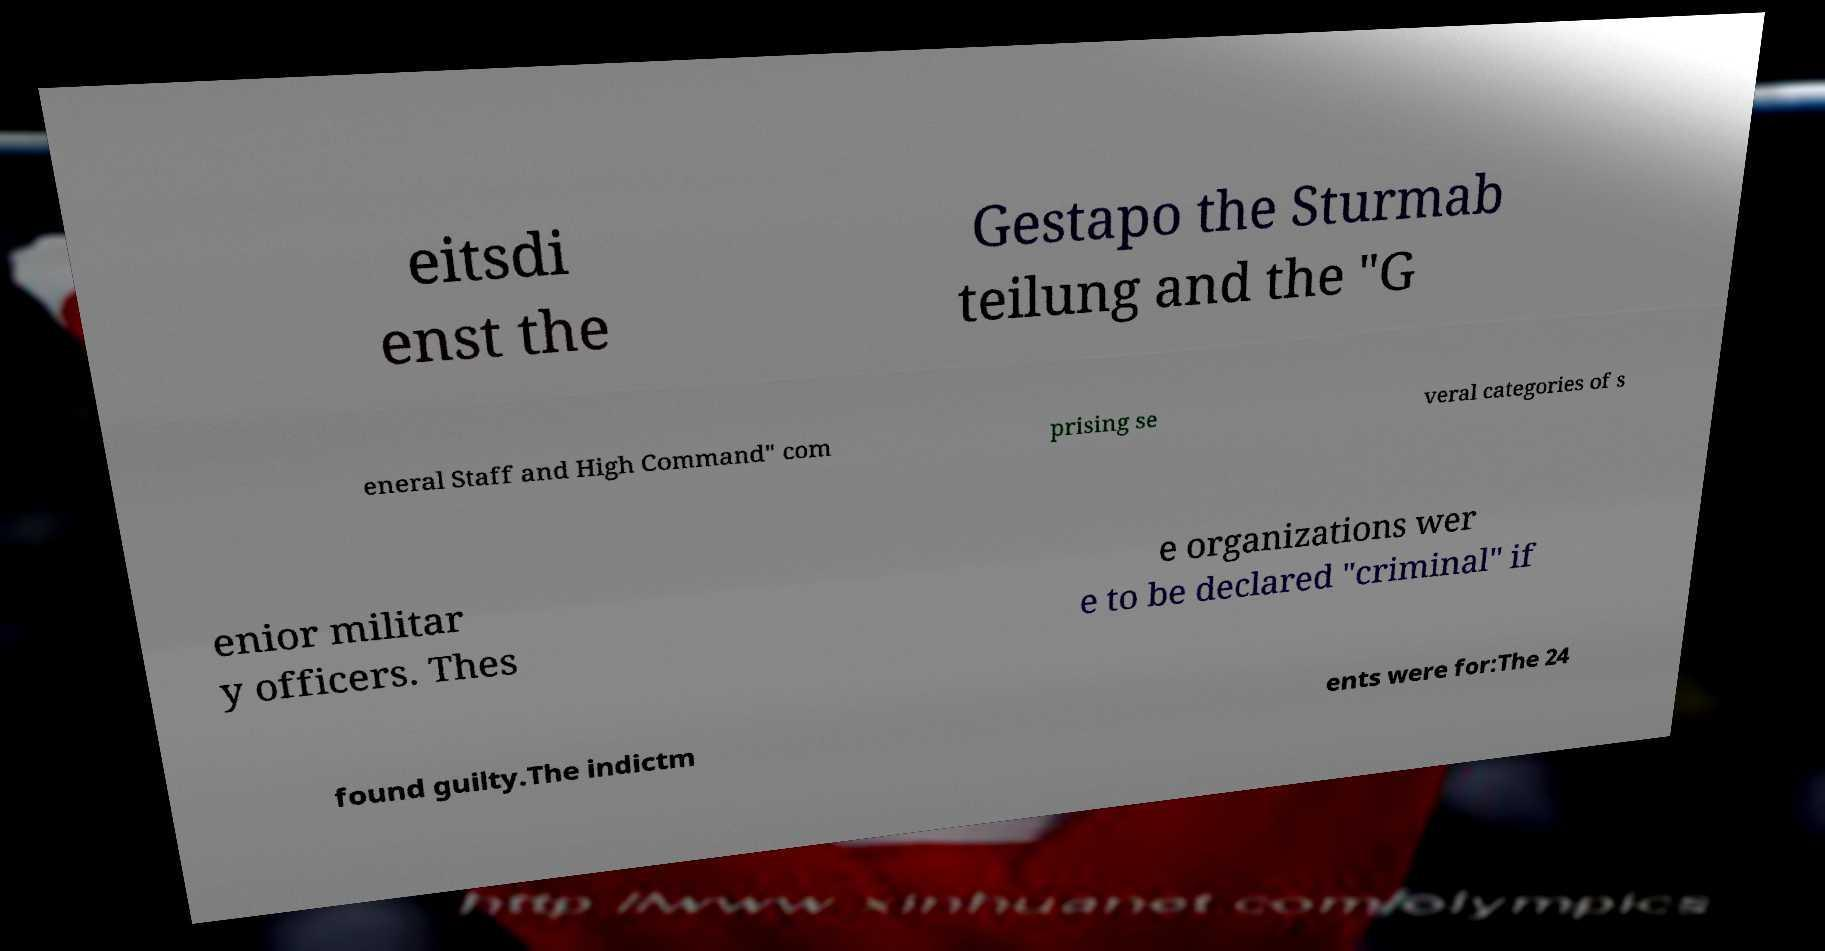Could you assist in decoding the text presented in this image and type it out clearly? eitsdi enst the Gestapo the Sturmab teilung and the "G eneral Staff and High Command" com prising se veral categories of s enior militar y officers. Thes e organizations wer e to be declared "criminal" if found guilty.The indictm ents were for:The 24 